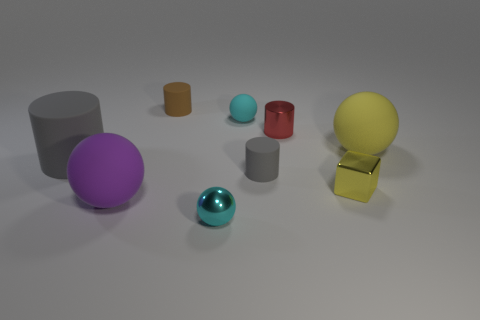What number of objects are either tiny cylinders that are in front of the small brown matte object or cyan balls in front of the tiny cyan matte ball? Upon examining the image, I can confirm there are three objects that fit the criteria: one tiny cyan cylinder located in front of the small brown matte object and two cyan balls in front of the tiny cyan matte ball. 